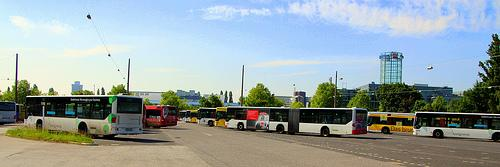List the different types of buses seen in the image. White bus with green marking, white bus with red panel, commercial bus mostly yellow, white bus with green and blue markings, red bus, and a white bus with red advertising panel. Communicate the central concept of the image in the fewest words possible. Varied buses on a busy street. Write a sentence capturing the most striking aspect of the image. The variety of buses, each with their unique features, creates a visually captivating scene on the crowded road. Describe the image as if you're speaking to someone who cannot see it. Picture a street filled with several buses, each showcasing different colors and patterns, surrounded by a tall building and a sky partially covered by clouds. Describe the scene captured in the image using a poetic style. A symphony of buses, each with their unique colors and markings, assemble in harmony beneath the watchful tower and the embrace of the cloudy sky. Imagine the image is part of a story. Provide a brief description of the scene. In the bustling city, various colorful buses have gathered on a busy street, preparing for their daily journeys under the towering buildings and ever-changing sky. Mention the main elements in the image using simple language. There are many buses, a tall building, and a sky with clouds in the picture. Provide a brief description of the primary focus of the image. The image primarily features multiple buses parked on a road, with a tall building and cloudy sky in the background. State the primary theme and mood of the image. The primary theme is transportation, and the mood is crowded and bustling. Categorize the elements within the image using concise language. Buses: multiple, various colors; Building: tall, sky: cloudy; Road: crowded. 